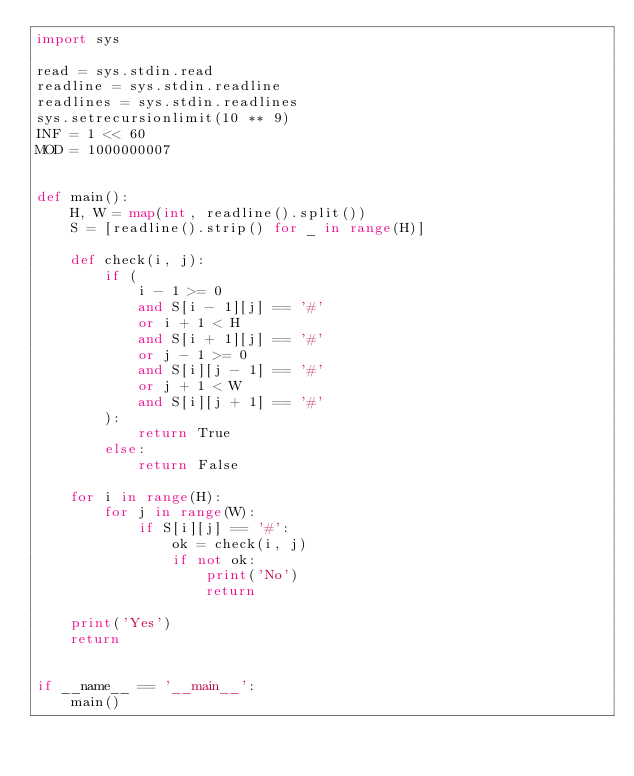Convert code to text. <code><loc_0><loc_0><loc_500><loc_500><_Python_>import sys

read = sys.stdin.read
readline = sys.stdin.readline
readlines = sys.stdin.readlines
sys.setrecursionlimit(10 ** 9)
INF = 1 << 60
MOD = 1000000007


def main():
    H, W = map(int, readline().split())
    S = [readline().strip() for _ in range(H)]

    def check(i, j):
        if (
            i - 1 >= 0
            and S[i - 1][j] == '#'
            or i + 1 < H
            and S[i + 1][j] == '#'
            or j - 1 >= 0
            and S[i][j - 1] == '#'
            or j + 1 < W
            and S[i][j + 1] == '#'
        ):
            return True
        else:
            return False

    for i in range(H):
        for j in range(W):
            if S[i][j] == '#':
                ok = check(i, j)
                if not ok:
                    print('No')
                    return

    print('Yes')
    return


if __name__ == '__main__':
    main()
</code> 